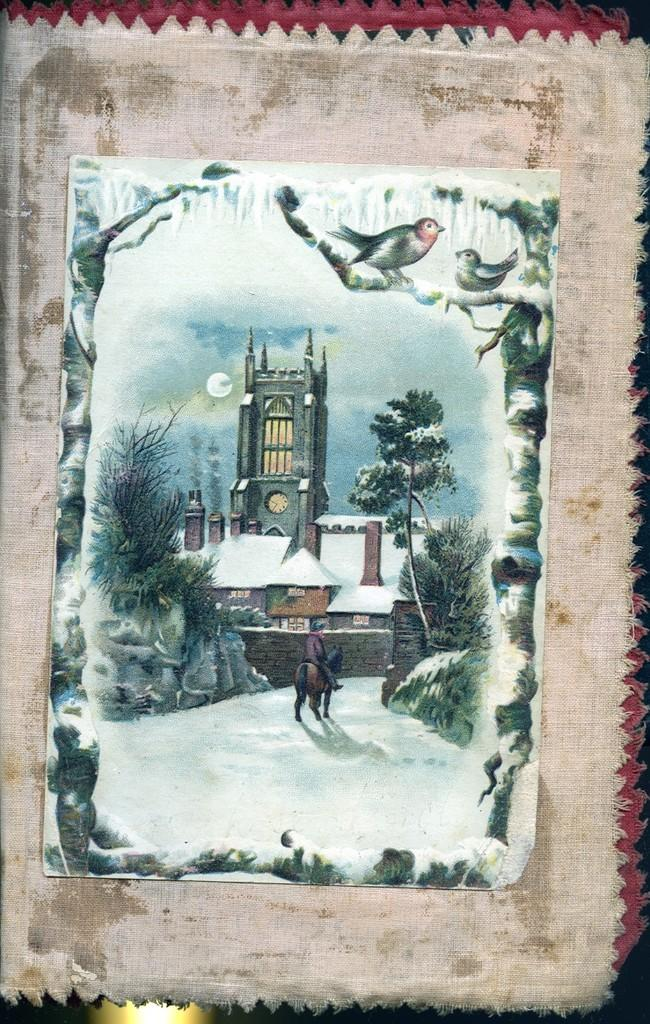What is the main subject of the image? There is a painting in the image. How is the painting being displayed or protected? The painting is in a cloth. Where is the painting located within the image? The painting is in the center of the image. How many legs are visible in the image? There are no legs visible in the image; it features a painting in a cloth. What time of day is depicted in the image? The image does not depict a specific time of day; it only shows a painting in a cloth. 